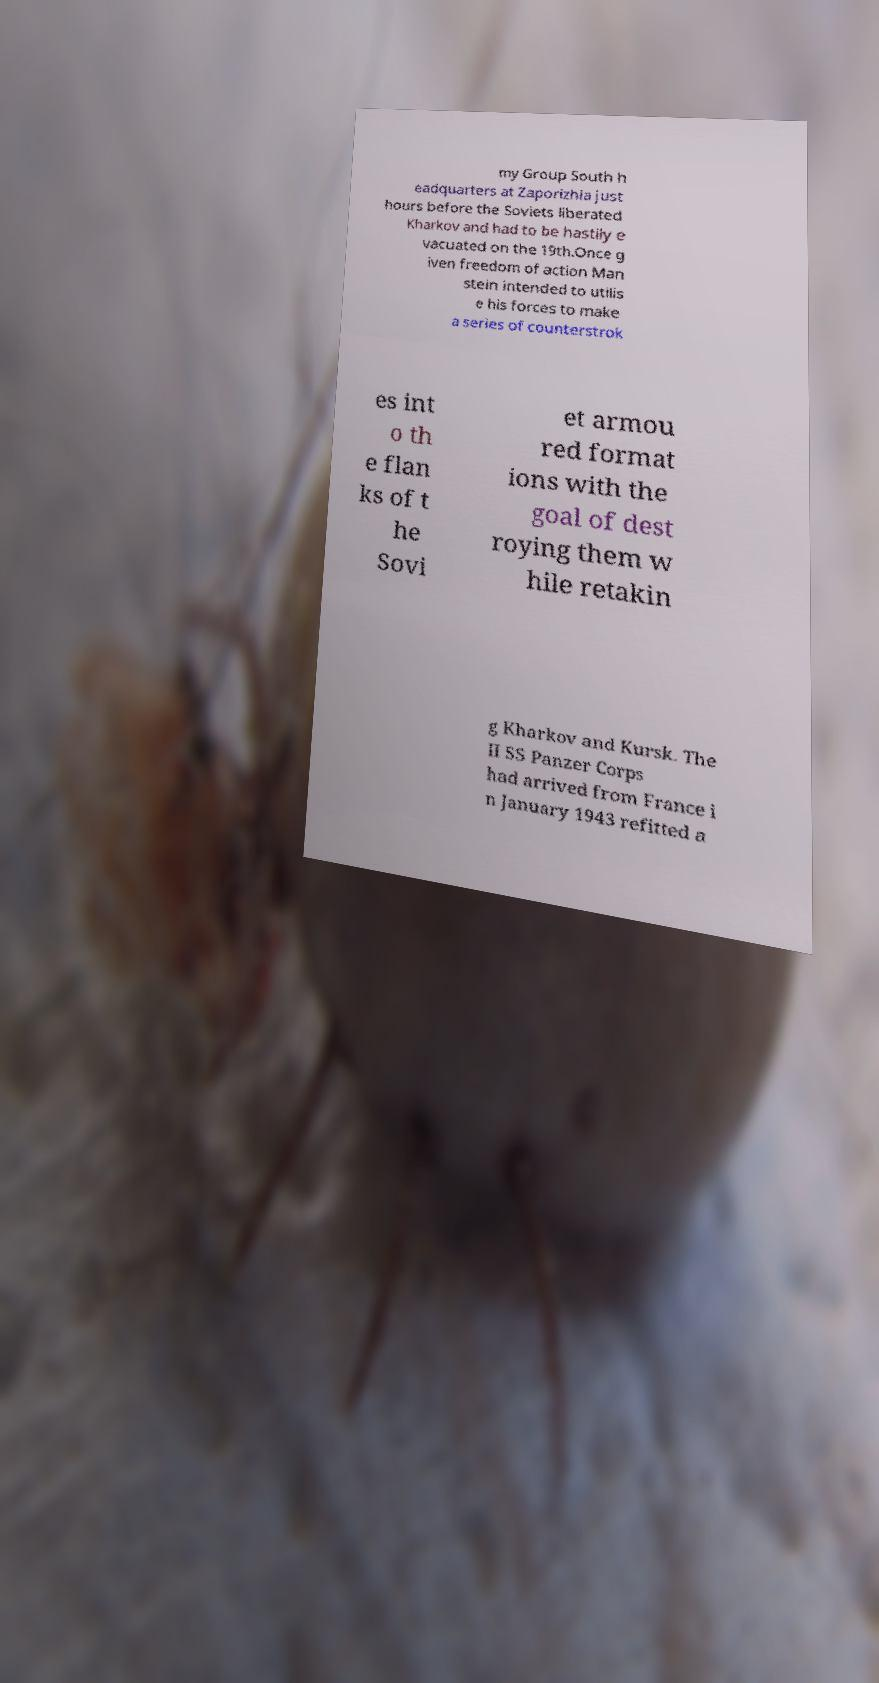What messages or text are displayed in this image? I need them in a readable, typed format. my Group South h eadquarters at Zaporizhia just hours before the Soviets liberated Kharkov and had to be hastily e vacuated on the 19th.Once g iven freedom of action Man stein intended to utilis e his forces to make a series of counterstrok es int o th e flan ks of t he Sovi et armou red format ions with the goal of dest roying them w hile retakin g Kharkov and Kursk. The II SS Panzer Corps had arrived from France i n January 1943 refitted a 